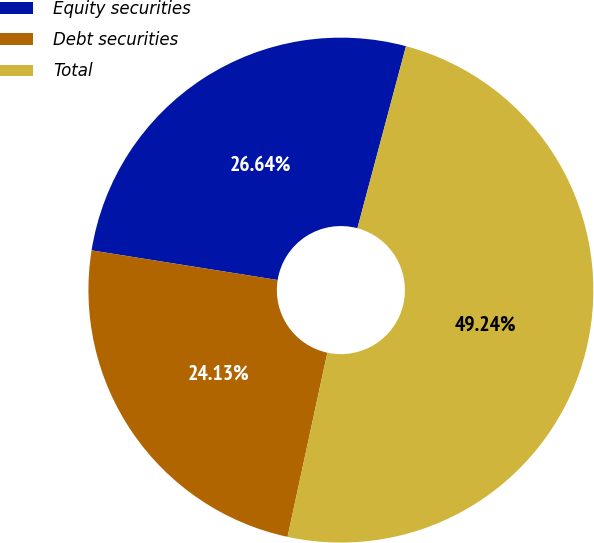Convert chart to OTSL. <chart><loc_0><loc_0><loc_500><loc_500><pie_chart><fcel>Equity securities<fcel>Debt securities<fcel>Total<nl><fcel>26.64%<fcel>24.13%<fcel>49.24%<nl></chart> 